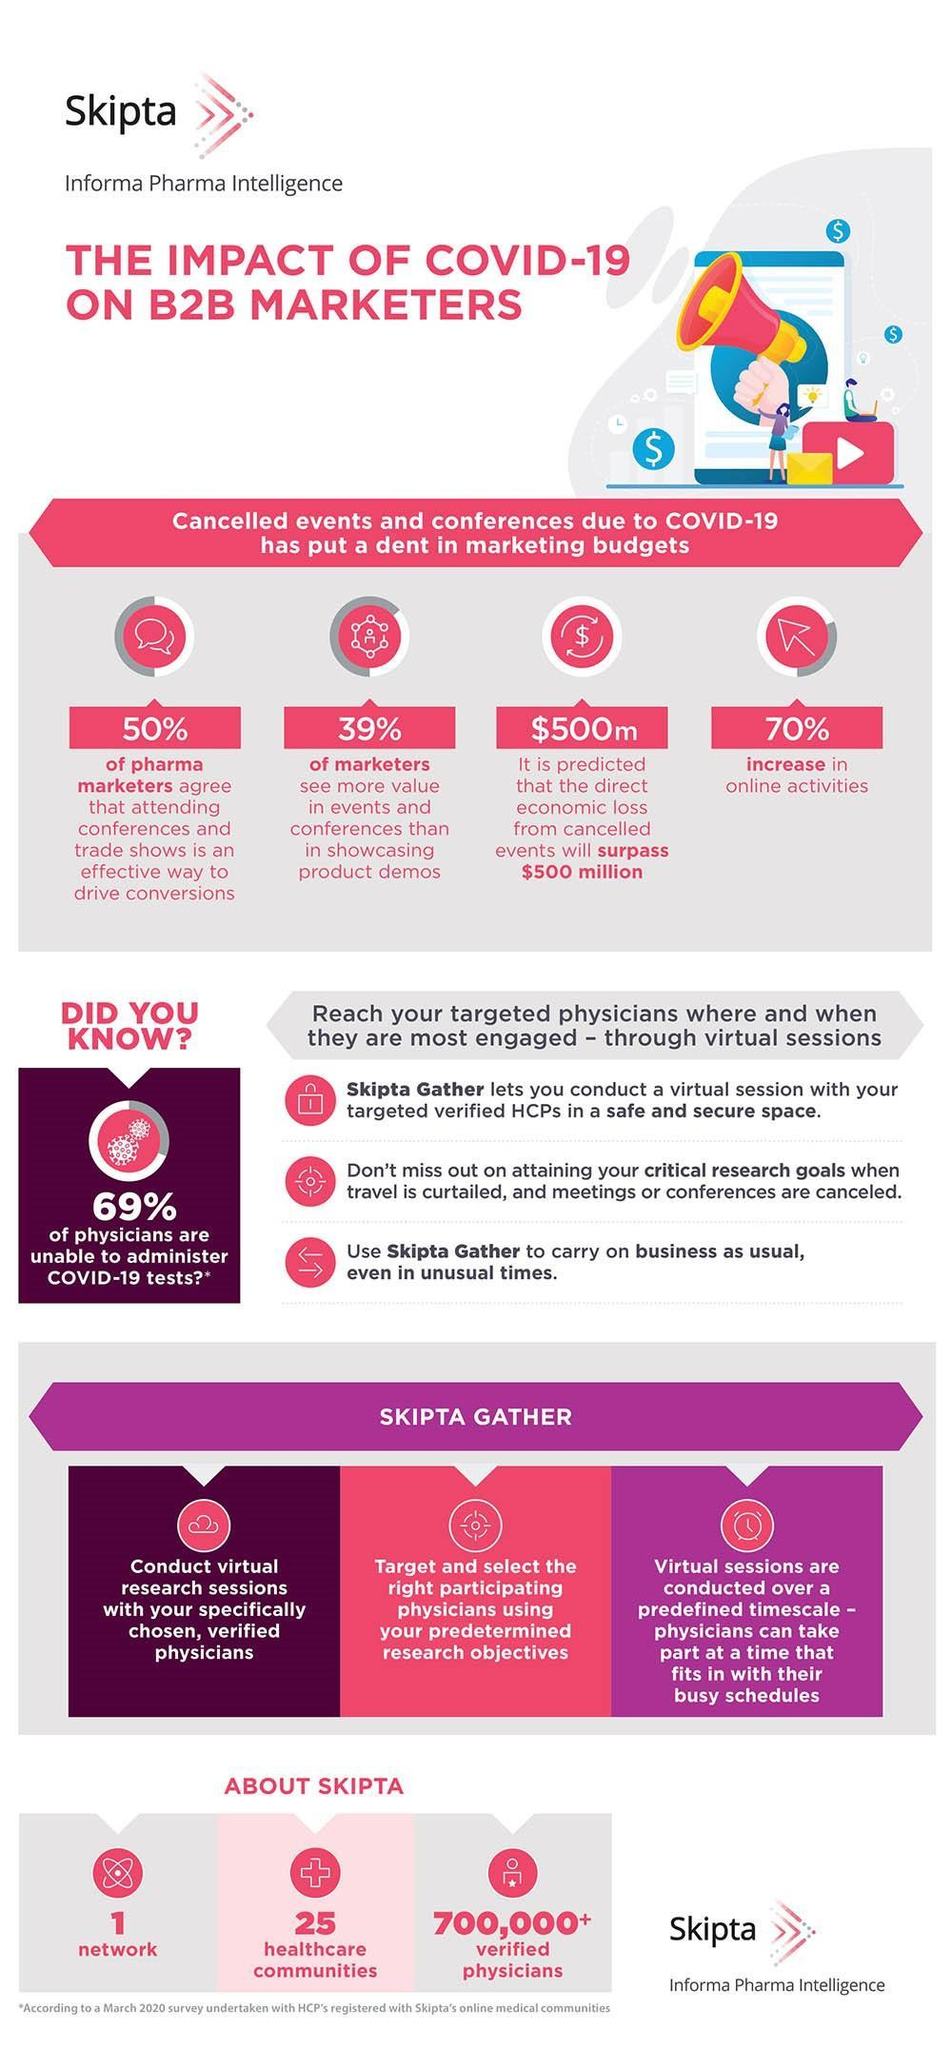What percentage of pharma marketers agree that attending conferences and trade shows is an effective way to drive conversions?
Answer the question with a short phrase. 50% What percentage of marketers see more value in events and conferences than in showcasing product demos? 39% How many healthcare communities? 25 How many networks? 1 